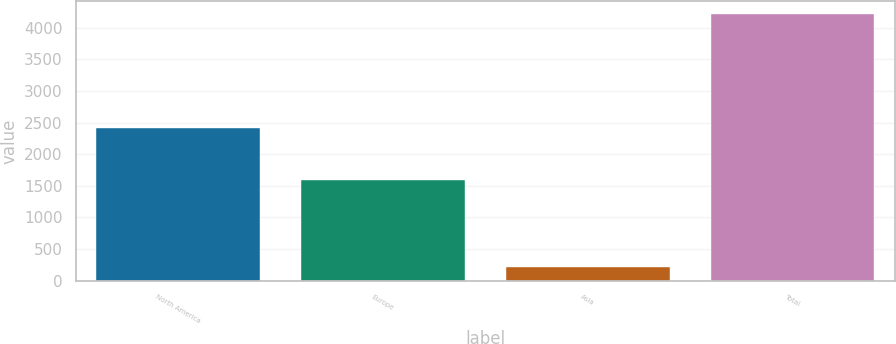<chart> <loc_0><loc_0><loc_500><loc_500><bar_chart><fcel>North America<fcel>Europe<fcel>Asia<fcel>Total<nl><fcel>2412<fcel>1589<fcel>211<fcel>4212<nl></chart> 